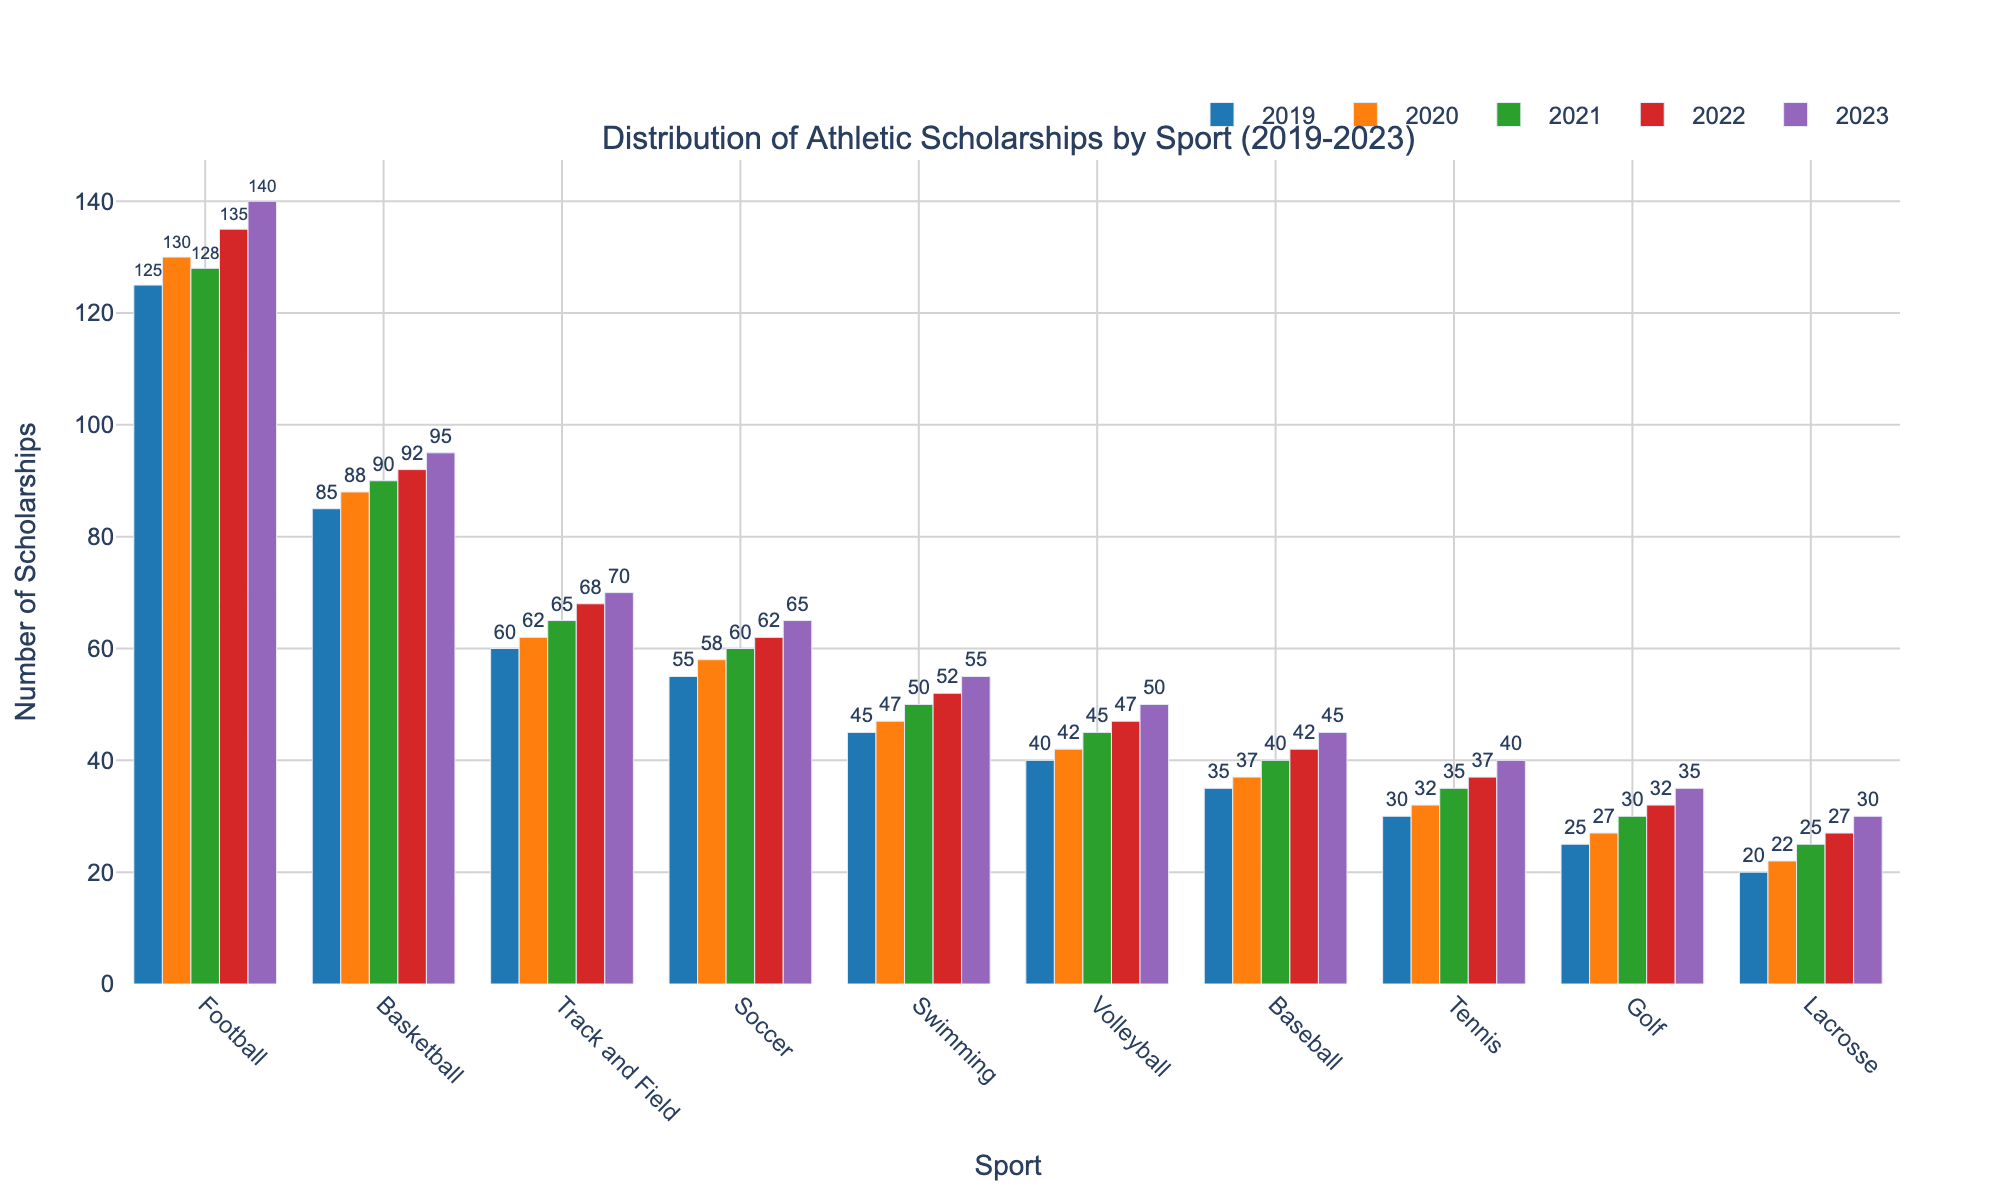What is the total number of scholarships awarded across all sports in 2023? To find the total number of scholarships awarded across all sports in 2023, sum the values for each sport in 2023: 140 (Football) + 95 (Basketball) + 70 (Track and Field) + 65 (Soccer) + 55 (Swimming) + 50 (Volleyball) + 45 (Baseball) + 40 (Tennis) + 35 (Golf) + 30 (Lacrosse) = 625
Answer: 625 Which sport saw the greatest increase in scholarships from 2019 to 2023? To determine which sport had the greatest increase in scholarships from 2019 to 2023, calculate the difference for each sport and compare:  
Football: 140 - 125 = 15  
Basketball: 95 - 85 = 10  
Track and Field: 70 - 60 = 10  
Soccer: 65 - 55 = 10  
Swimming: 55 - 45 = 10  
Volleyball: 50 - 40 = 10  
Baseball: 45 - 35 = 10  
Tennis: 40 - 30 = 10  
Golf: 35 - 25 = 10  
Lacrosse: 30 - 20 = 10  
The sport with the greatest increase is Football (15)
Answer: Football Which year had the highest number of scholarships awarded in Football? Look at the values of Football scholarships each year and identify the highest number: 125 (2019), 130 (2020), 128 (2021), 135 (2022), 140 (2023); the highest value is in 2023
Answer: 2023 Was there any sport with the same number of scholarships awarded in any two consecutive years? Examine the values year by year for each sport to find if any have the same number:
Football: No  
Basketball: No  
Track and Field: No  
Soccer: No  
Swimming: No  
Volleyball: No  
Baseball: No  
Tennis: No  
Golf: No  
Lacrosse: No
Answer: No On average, how many scholarships were awarded for Basketball over the 5 years? To find the average number of Basketball scholarships, sum the yearly values and divide by 5: (85 + 88 + 90 + 92 + 95) / 5 = 450 / 5 = 90
Answer: 90 Which sport had the smallest amount of scholarships awarded in 2019 and how many were awarded? Look for the smallest value in the 2019 data column: Football (125), Basketball (85), Track and Field (60), Soccer (55), Swimming (45), Volleyball (40), Baseball (35), Tennis (30), Golf (25), Lacrosse (20); Lacrosse had the smallest amount with 20
Answer: Lacrosse, 20 Which sport had the most consistent number of scholarships across the 5 years (least variance)? Calculate the variance for each sport and compare:  
Football: variance = ([(125-131.6)^2 + (130-131.6)^2 + (128-131.6)^2 + (135-131.6)^2 + (140-131.6)^2]/5) = 33.2  
Basketball: variance = ([(85-90)^2 + (88-90)^2 + (90-90)^2 + (92-90)^2 + (95-90)^2]/5) = 18  
Track and Field: variance = ([(60-65)^2 + (62-65)^2 + (65-65)^2 + (68-65)^2 + (70-65)^2]/5) = 14  
Soccer: variance = ([(55-60)^2 + (58-60)^2 + (60-60)^2 + (62-60)^2 + (65-60)^2]/5) = 14  
Swimming: variance = ([(45-49.8)^2 + (47-49.8)^2 + (50-49.8)^2 + (52-49.8)^2 + (55-49.8)^2]/5) = 10.56  
Volleyball: variance = ([(40-44.8)^2 + (42-44.8)^2 + (45-44.8)^2 + (47-44.8)^2 + (50-44.8)^2]/5) = 20.56  
Baseball: variance = ([(35-39.8)^2 + (37-39.8)^2 + (40-39.8)^2 + (42-39.8)^2 + (45-39.8)^2]/5) = 15.76  
Tennis: variance = ([(30-34.8)^2 + (32-34.8)^2 + (35-34.8)^2 + (37-34.8)^2 + (40-34.8)^2]/5) = 18.56  
Golf: variance = ([(25-29.8)^2 + (27-29.8)^2 + (30-29.8)^2 + (32-29.8)^2 + (35-29.8)^2]/5) = 12.56  
Lacrosse: variance = ([(20-24.8)^2 + (22-24.8)^2 + (25-24.8)^2 + (27-24.8)^2 + (30-24.8)^2]/5) = 14.56  
Swimming had the lowest variance (10.56), thus the most consistent
Answer: Swimming 